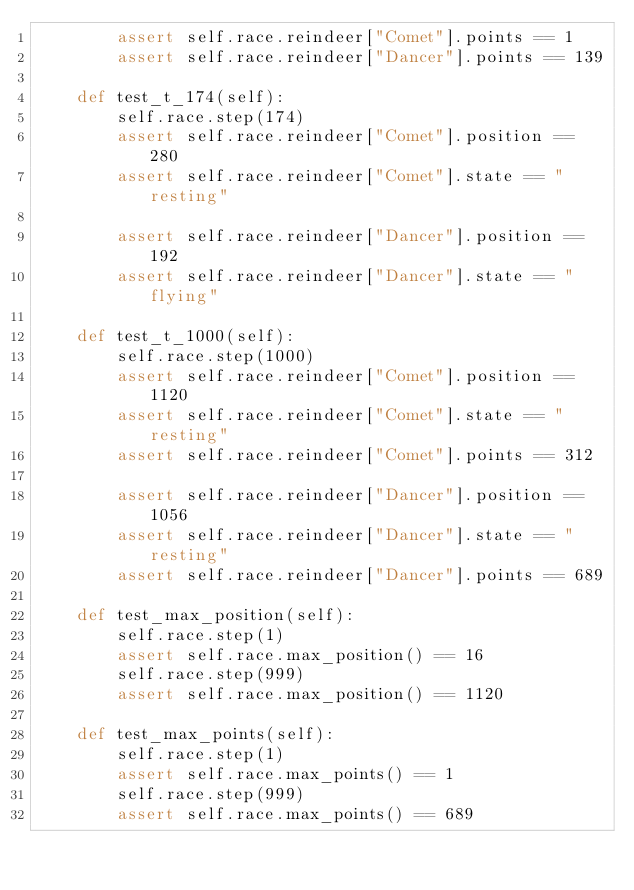<code> <loc_0><loc_0><loc_500><loc_500><_Python_>        assert self.race.reindeer["Comet"].points == 1
        assert self.race.reindeer["Dancer"].points == 139

    def test_t_174(self):
        self.race.step(174)
        assert self.race.reindeer["Comet"].position == 280
        assert self.race.reindeer["Comet"].state == "resting"

        assert self.race.reindeer["Dancer"].position == 192
        assert self.race.reindeer["Dancer"].state == "flying"

    def test_t_1000(self):
        self.race.step(1000)
        assert self.race.reindeer["Comet"].position == 1120
        assert self.race.reindeer["Comet"].state == "resting"
        assert self.race.reindeer["Comet"].points == 312

        assert self.race.reindeer["Dancer"].position == 1056
        assert self.race.reindeer["Dancer"].state == "resting"
        assert self.race.reindeer["Dancer"].points == 689

    def test_max_position(self):
        self.race.step(1)
        assert self.race.max_position() == 16
        self.race.step(999)
        assert self.race.max_position() == 1120

    def test_max_points(self):
        self.race.step(1)
        assert self.race.max_points() == 1
        self.race.step(999)
        assert self.race.max_points() == 689
</code> 